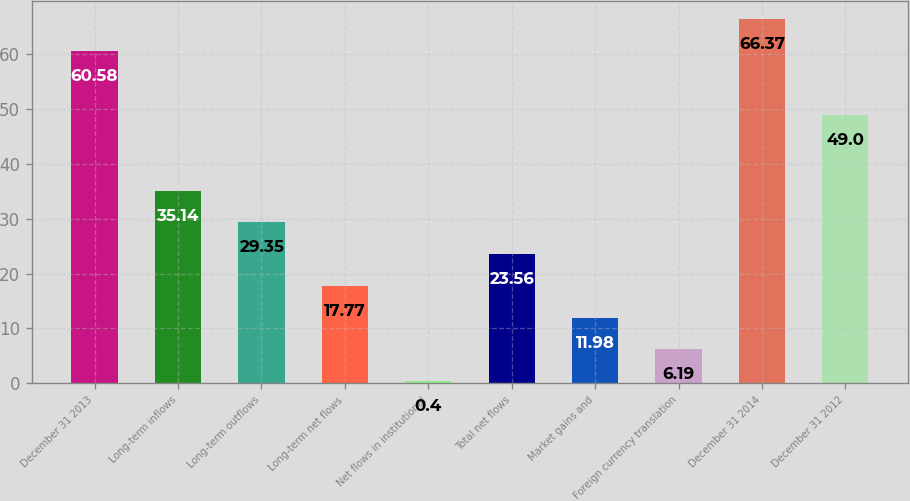Convert chart. <chart><loc_0><loc_0><loc_500><loc_500><bar_chart><fcel>December 31 2013<fcel>Long-term inflows<fcel>Long-term outflows<fcel>Long-term net flows<fcel>Net flows in institutional<fcel>Total net flows<fcel>Market gains and<fcel>Foreign currency translation<fcel>December 31 2014<fcel>December 31 2012<nl><fcel>60.58<fcel>35.14<fcel>29.35<fcel>17.77<fcel>0.4<fcel>23.56<fcel>11.98<fcel>6.19<fcel>66.37<fcel>49<nl></chart> 